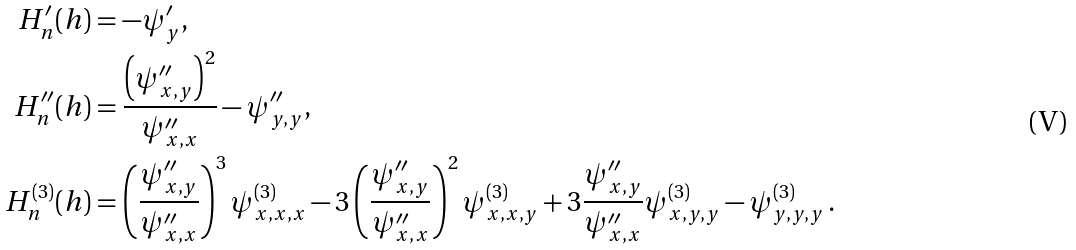Convert formula to latex. <formula><loc_0><loc_0><loc_500><loc_500>H ^ { \prime } _ { n } ( h ) & = - \psi ^ { \prime } _ { y } , \\ H ^ { \prime \prime } _ { n } ( h ) & = \frac { \left ( \psi ^ { \prime \prime } _ { x , y } \right ) ^ { 2 } } { \psi ^ { \prime \prime } _ { x , x } } - \psi ^ { \prime \prime } _ { y , y } , \\ H ^ { ( 3 ) } _ { n } ( h ) & = \left ( \frac { \psi ^ { \prime \prime } _ { x , y } } { \psi ^ { \prime \prime } _ { x , x } } \right ) ^ { 3 } \psi ^ { ( 3 ) } _ { x , x , x } - 3 \left ( \frac { \psi ^ { \prime \prime } _ { x , y } } { \psi ^ { \prime \prime } _ { x , x } } \right ) ^ { 2 } \psi ^ { ( 3 ) } _ { x , x , y } + 3 \frac { \psi ^ { \prime \prime } _ { x , y } } { \psi ^ { \prime \prime } _ { x , x } } \psi ^ { ( 3 ) } _ { x , y , y } - \psi ^ { ( 3 ) } _ { y , y , y } \, .</formula> 